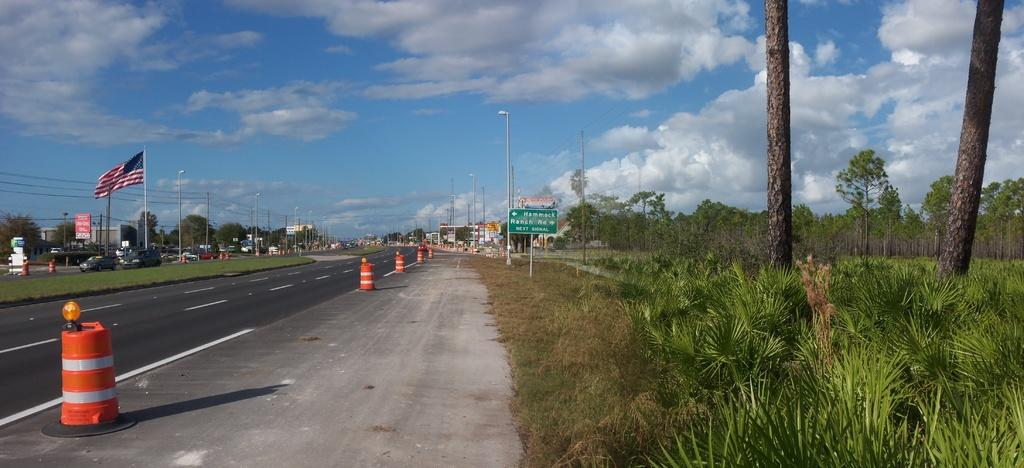What type of vegetation can be seen in the image? There are trees in the image. What structures are present in the image? There are poles, light poles, buildings, and traffic poles in the image. What other objects can be seen in the image? There are wires, signboards, and vehicles on the road in the image. What is the color of the sky in the image? The sky is blue and white in color. What type of ground surface is visible in the image? There is grass in the image. Can you tell me how many pens are visible in the image? There are no pens present in the image. What type of shoes can be seen on the toes of the people in the image? There are no people or shoes visible in the image. 